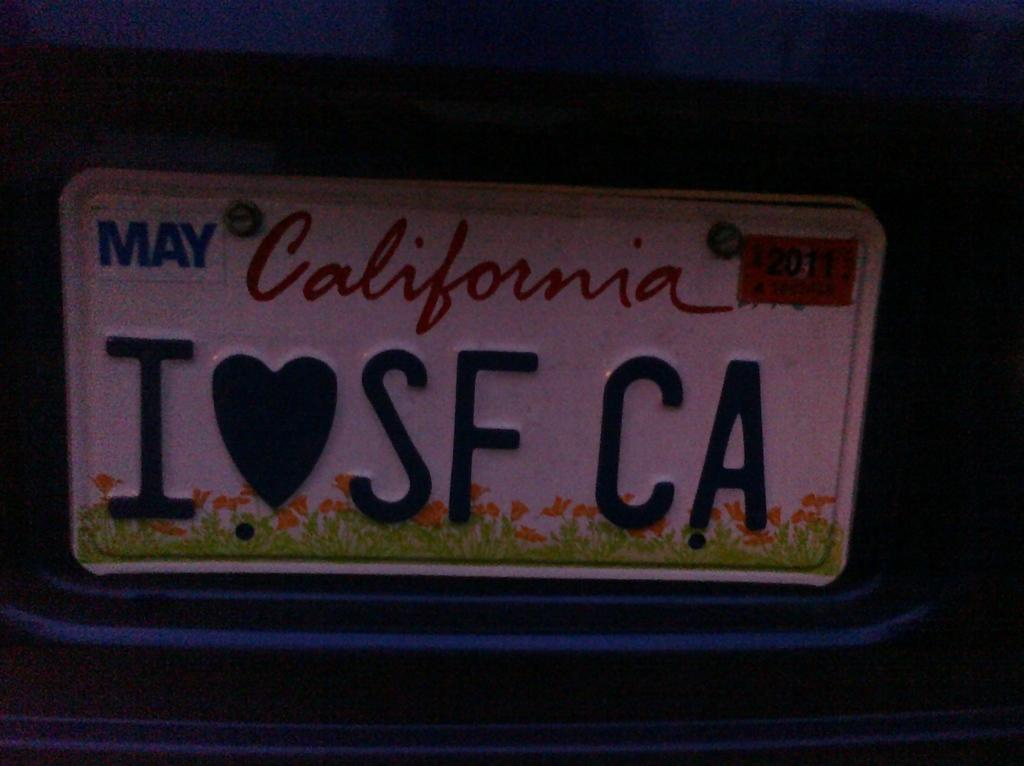What is the main object in the image? There is a board in the image. What is on the board? There is writing on the board. What can be observed about the overall appearance of the image? The background of the image is dark. Can you see a boat in the image? There is no boat present in the image. What type of smile can be seen on the board? There is no smile depicted on the board; it only contains writing. 